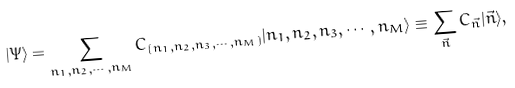<formula> <loc_0><loc_0><loc_500><loc_500>| \Psi \rangle = \sum _ { n _ { 1 } , n _ { 2 } , \cdots , n _ { M } } C _ { ( n _ { 1 } , n _ { 2 } , n _ { 3 } , \cdots , n _ { M } ) } | n _ { 1 } , n _ { 2 } , n _ { 3 } , \cdots , n _ { M } \rangle \equiv \sum _ { \vec { n } } C _ { \vec { n } } | \vec { n } \rangle ,</formula> 